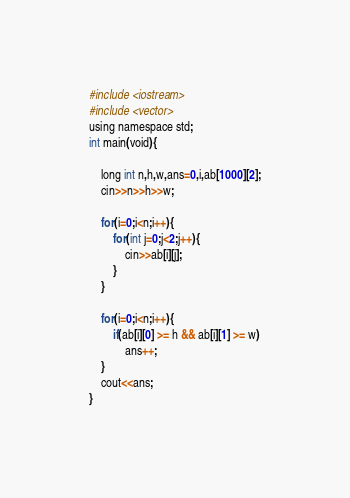<code> <loc_0><loc_0><loc_500><loc_500><_Python_>#include <iostream>
#include <vector>
using namespace std;
int main(void){
    
    long int n,h,w,ans=0,i,ab[1000][2];
    cin>>n>>h>>w;
    
    for(i=0;i<n;i++){
        for(int j=0;j<2;j++){
            cin>>ab[i][j];
        }
    }
    
    for(i=0;i<n;i++){
        if(ab[i][0] >= h && ab[i][1] >= w)
            ans++;
    }
    cout<<ans;
}</code> 